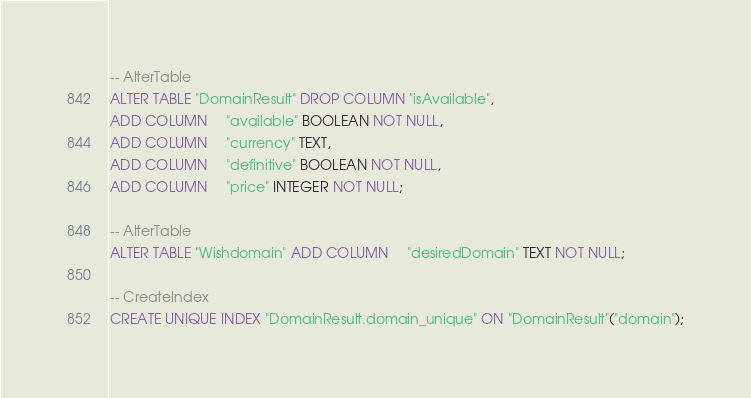Convert code to text. <code><loc_0><loc_0><loc_500><loc_500><_SQL_>-- AlterTable
ALTER TABLE "DomainResult" DROP COLUMN "isAvailable",
ADD COLUMN     "available" BOOLEAN NOT NULL,
ADD COLUMN     "currency" TEXT,
ADD COLUMN     "definitive" BOOLEAN NOT NULL,
ADD COLUMN     "price" INTEGER NOT NULL;

-- AlterTable
ALTER TABLE "Wishdomain" ADD COLUMN     "desiredDomain" TEXT NOT NULL;

-- CreateIndex
CREATE UNIQUE INDEX "DomainResult.domain_unique" ON "DomainResult"("domain");
</code> 